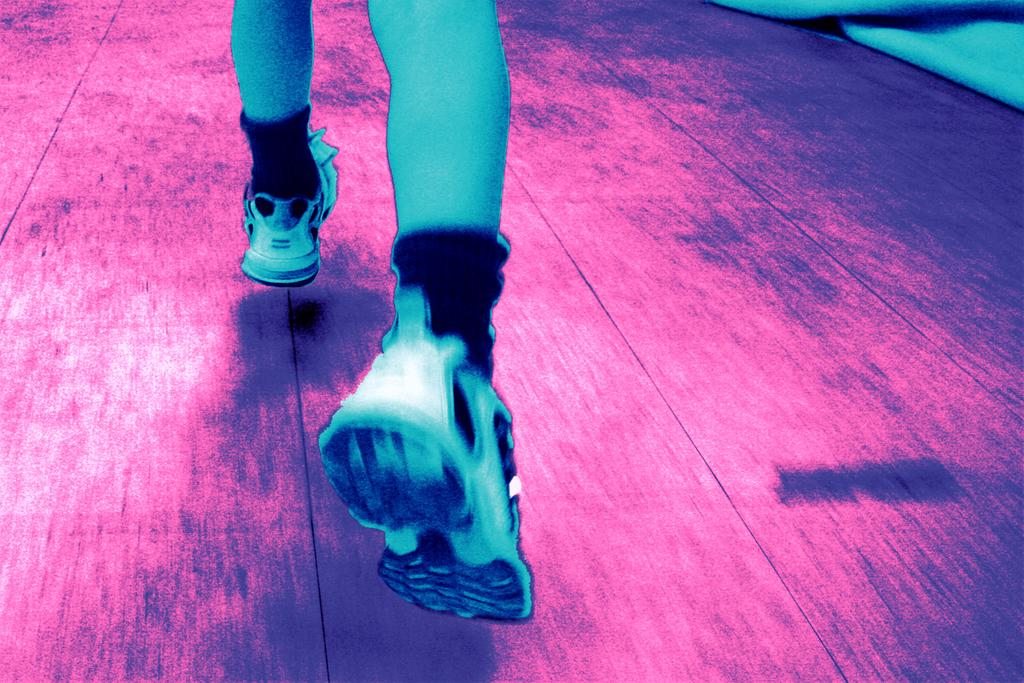What is the person in the image doing? The person in the image is running. What is the surface that the person is running on? There is a floor at the bottom of the image. What can be seen at the top right of the image? There is a cloth visible at the top right of the image. What does the brother say about the aftermath of the race in the image? There is no brother or race present in the image, so it is not possible to answer that question. 